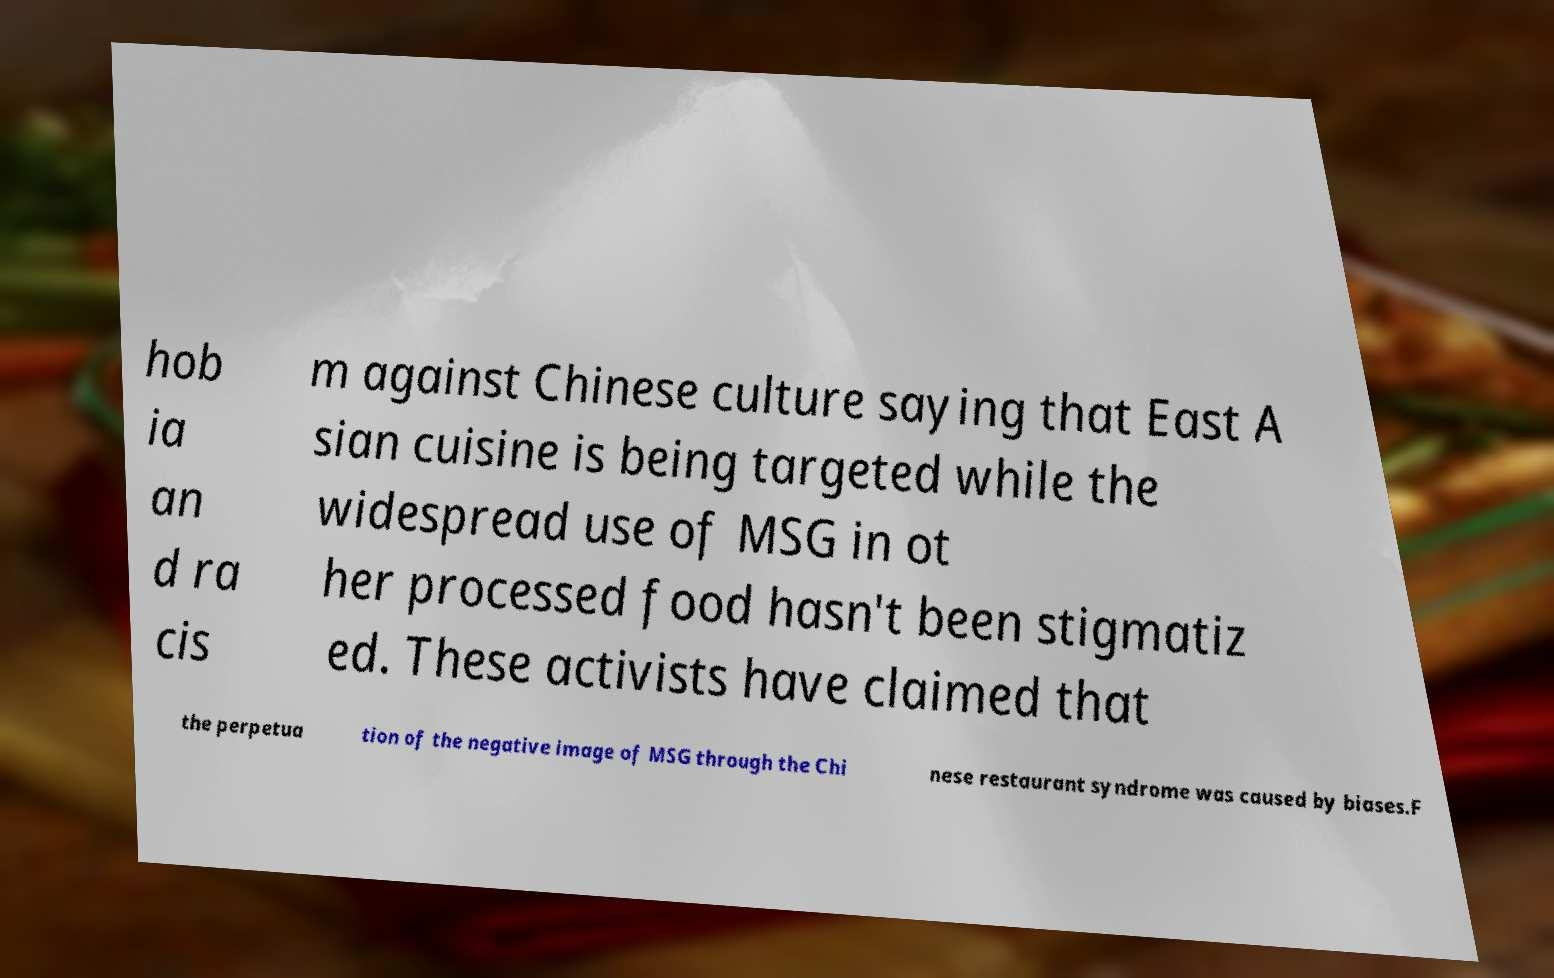Can you read and provide the text displayed in the image?This photo seems to have some interesting text. Can you extract and type it out for me? hob ia an d ra cis m against Chinese culture saying that East A sian cuisine is being targeted while the widespread use of MSG in ot her processed food hasn't been stigmatiz ed. These activists have claimed that the perpetua tion of the negative image of MSG through the Chi nese restaurant syndrome was caused by biases.F 